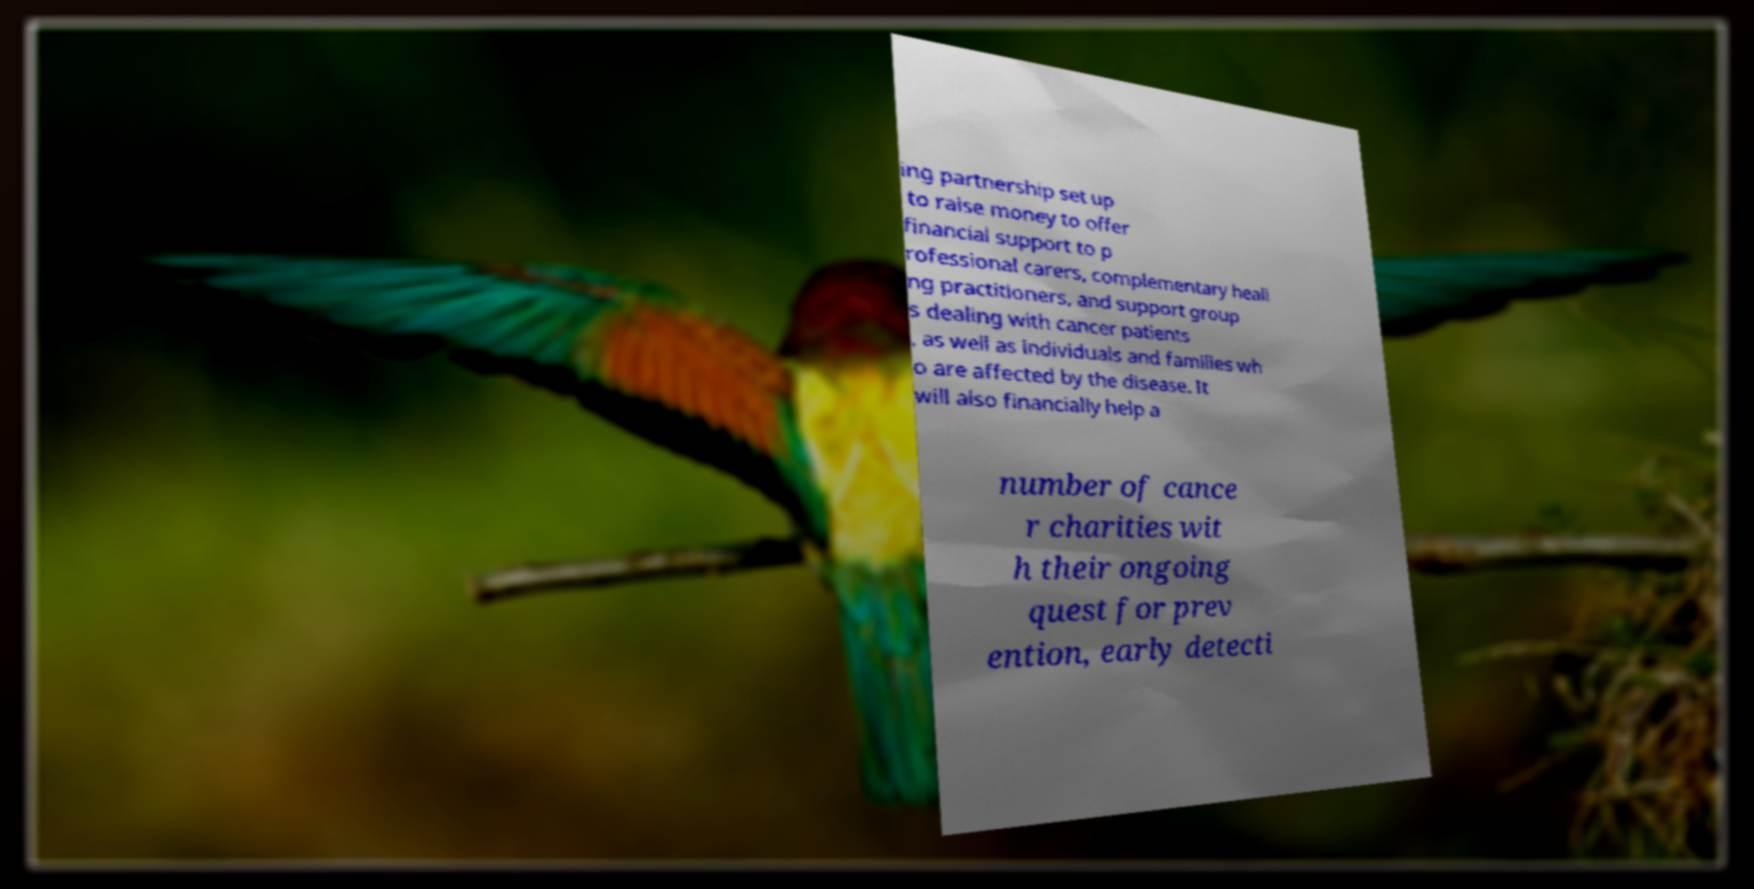For documentation purposes, I need the text within this image transcribed. Could you provide that? ing partnership set up to raise money to offer financial support to p rofessional carers, complementary heali ng practitioners, and support group s dealing with cancer patients , as well as individuals and families wh o are affected by the disease. It will also financially help a number of cance r charities wit h their ongoing quest for prev ention, early detecti 